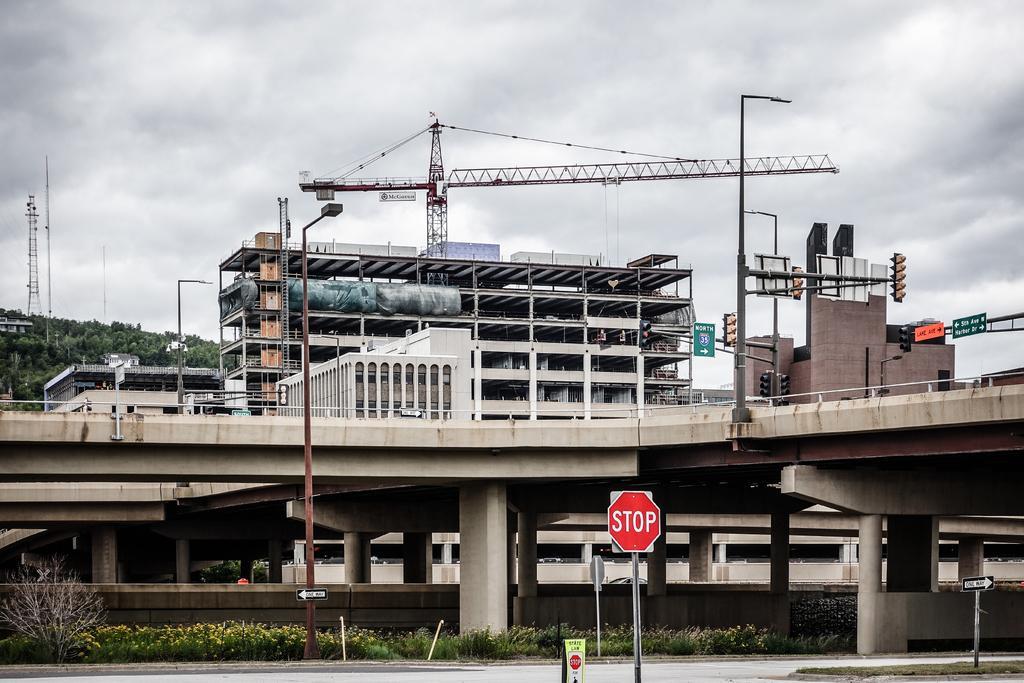Can you describe this image briefly? In the picture I can see few boards which is attached to the pole below it and there are few plants in the left corner and there is a bridge beside it and there are few buildings,traffic signals,cranes and trees in the background and the sky is cloudy. 